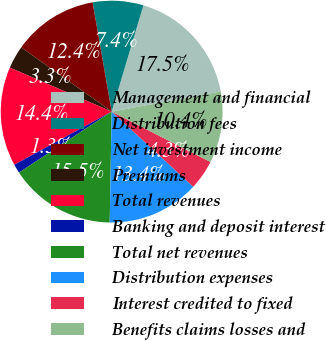Convert chart. <chart><loc_0><loc_0><loc_500><loc_500><pie_chart><fcel>Management and financial<fcel>Distribution fees<fcel>Net investment income<fcel>Premiums<fcel>Total revenues<fcel>Banking and deposit interest<fcel>Total net revenues<fcel>Distribution expenses<fcel>Interest credited to fixed<fcel>Benefits claims losses and<nl><fcel>17.47%<fcel>7.37%<fcel>12.42%<fcel>3.33%<fcel>14.44%<fcel>1.31%<fcel>15.45%<fcel>13.43%<fcel>4.34%<fcel>10.4%<nl></chart> 